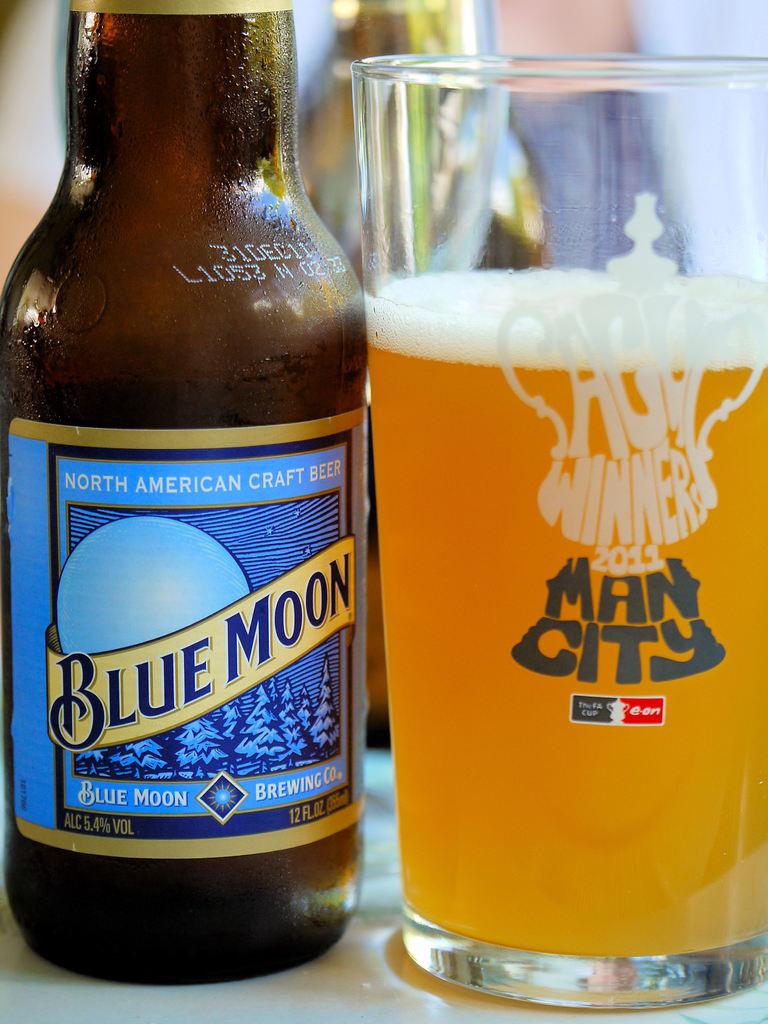What is the name of this north american craft beer?
Offer a terse response. Blue moon. What is written in gray on the glass to the right?
Provide a succinct answer. Man city. 